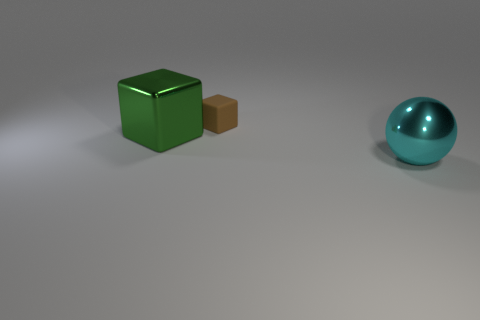What number of other objects are the same material as the green block?
Your answer should be very brief. 1. The big green thing that is the same material as the sphere is what shape?
Provide a succinct answer. Cube. Do the cyan metal thing and the green metallic cube have the same size?
Your response must be concise. Yes. There is a metal thing behind the metal object right of the brown rubber block; how big is it?
Keep it short and to the point. Large. What number of cubes are small yellow metal things or big green metallic things?
Provide a succinct answer. 1. Does the brown rubber thing have the same size as the metallic thing that is to the right of the small thing?
Ensure brevity in your answer.  No. Is the number of cyan objects to the left of the tiny rubber thing greater than the number of metal objects?
Ensure brevity in your answer.  No. What size is the cyan object that is made of the same material as the green block?
Keep it short and to the point. Large. Are there any big objects that have the same color as the tiny matte thing?
Keep it short and to the point. No. How many things are either green metallic blocks or large things to the left of the big cyan metal ball?
Offer a terse response. 1. 